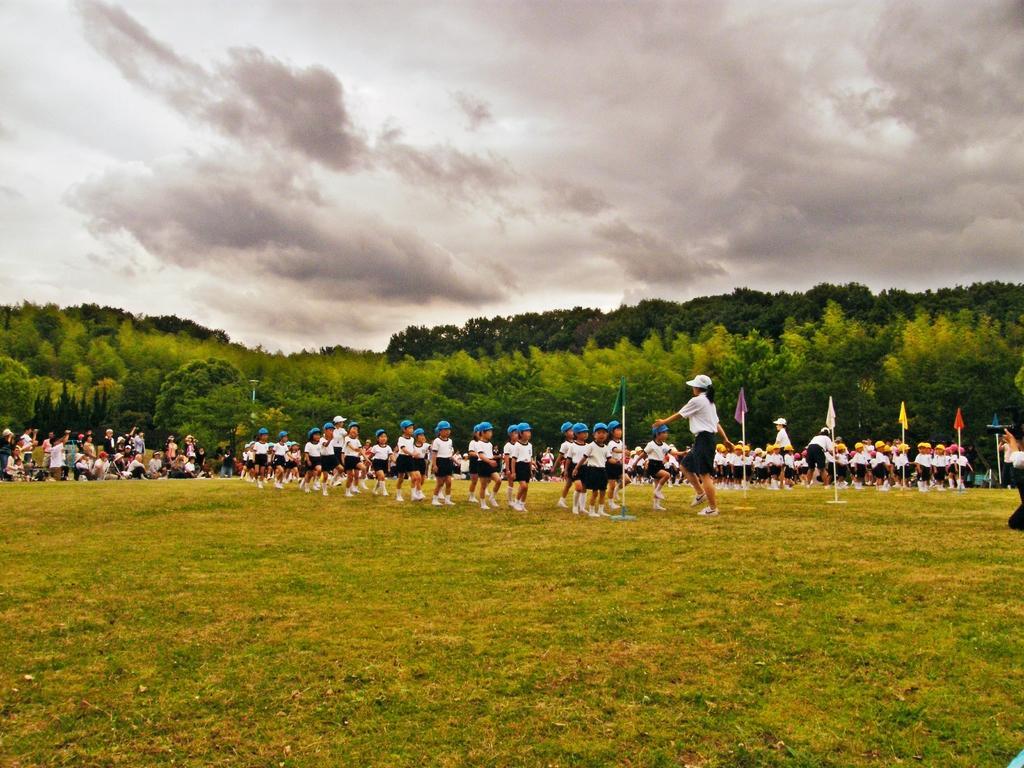Can you describe this image briefly? In this image on the right there is a woman, she wears a t shirt, trouser and cap. In the middle there are many children. On the right there are flags, people, children. On the left there are many people. At the bottom there is grass. In the background there are trees, sky and clouds. 